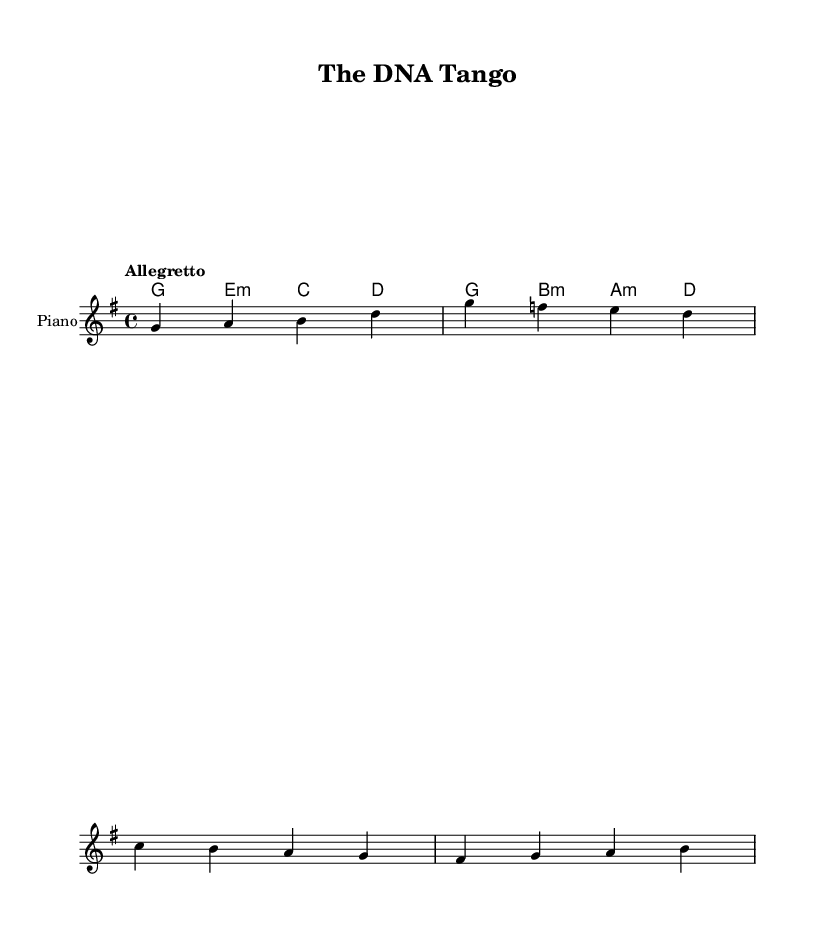What is the key signature of this music? The key signature is G major, indicated by one sharp (F#) in the key signature at the beginning of the staff.
Answer: G major What is the time signature of this piece? The time signature is 4/4, as seen at the beginning of the piece where it is noted as '4/4', meaning there are four beats per measure.
Answer: 4/4 What is the tempo marking for this piece? The tempo marking is "Allegretto," which suggests a moderately fast tempo, placed at the start of the score.
Answer: Allegretto How many measures are in the melody? The melody consists of 4 measures, as can be counted from the noted divisions in the notation of the melody.
Answer: 4 measures Which musical instrument is indicated for this score? The instrument indicated is the piano, noted at the beginning of the score under the staff.
Answer: Piano What type of chord is used in the first measure? The first measure contains a G major chord, which is identified by the G note and the accompanying harmony of E minor in the chord symbols.
Answer: G major 